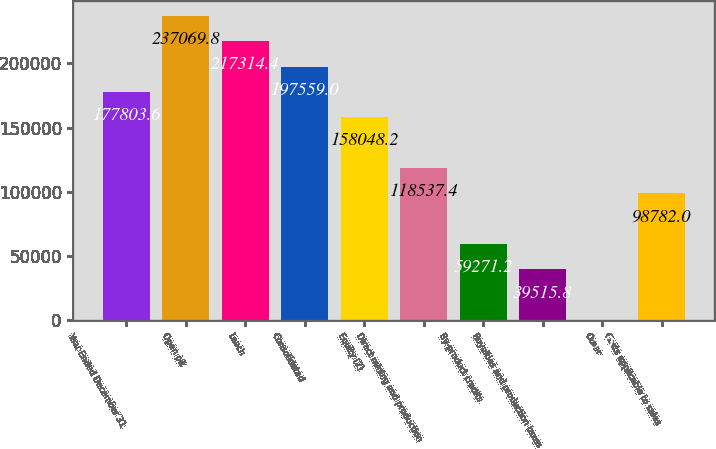<chart> <loc_0><loc_0><loc_500><loc_500><bar_chart><fcel>Year Ended December 31<fcel>Open pit<fcel>Leach<fcel>Consolidated<fcel>Equity (2)<fcel>Direct mining and production<fcel>By-product credits<fcel>Royalties and production taxes<fcel>Other<fcel>Costs applicable to sales<nl><fcel>177804<fcel>237070<fcel>217314<fcel>197559<fcel>158048<fcel>118537<fcel>59271.2<fcel>39515.8<fcel>5<fcel>98782<nl></chart> 